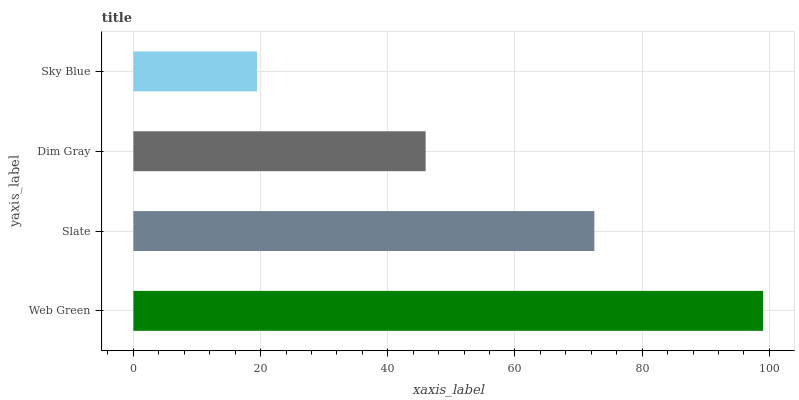Is Sky Blue the minimum?
Answer yes or no. Yes. Is Web Green the maximum?
Answer yes or no. Yes. Is Slate the minimum?
Answer yes or no. No. Is Slate the maximum?
Answer yes or no. No. Is Web Green greater than Slate?
Answer yes or no. Yes. Is Slate less than Web Green?
Answer yes or no. Yes. Is Slate greater than Web Green?
Answer yes or no. No. Is Web Green less than Slate?
Answer yes or no. No. Is Slate the high median?
Answer yes or no. Yes. Is Dim Gray the low median?
Answer yes or no. Yes. Is Web Green the high median?
Answer yes or no. No. Is Web Green the low median?
Answer yes or no. No. 